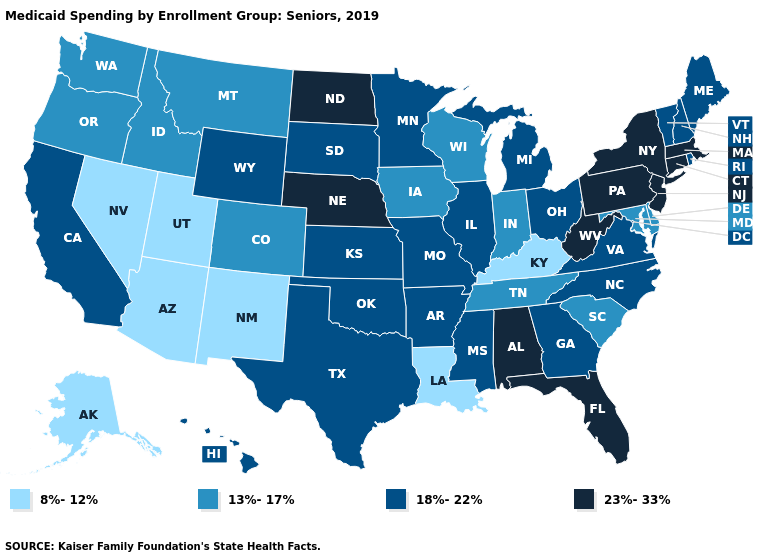What is the lowest value in the USA?
Short answer required. 8%-12%. Does Wyoming have the highest value in the West?
Keep it brief. Yes. What is the highest value in states that border Virginia?
Keep it brief. 23%-33%. What is the value of California?
Give a very brief answer. 18%-22%. Does the map have missing data?
Concise answer only. No. Name the states that have a value in the range 18%-22%?
Keep it brief. Arkansas, California, Georgia, Hawaii, Illinois, Kansas, Maine, Michigan, Minnesota, Mississippi, Missouri, New Hampshire, North Carolina, Ohio, Oklahoma, Rhode Island, South Dakota, Texas, Vermont, Virginia, Wyoming. Which states hav the highest value in the West?
Concise answer only. California, Hawaii, Wyoming. Does Maryland have the highest value in the South?
Give a very brief answer. No. Which states have the highest value in the USA?
Keep it brief. Alabama, Connecticut, Florida, Massachusetts, Nebraska, New Jersey, New York, North Dakota, Pennsylvania, West Virginia. How many symbols are there in the legend?
Concise answer only. 4. What is the value of Massachusetts?
Give a very brief answer. 23%-33%. What is the value of Colorado?
Give a very brief answer. 13%-17%. What is the value of Maine?
Quick response, please. 18%-22%. What is the highest value in the USA?
Short answer required. 23%-33%. Which states hav the highest value in the South?
Answer briefly. Alabama, Florida, West Virginia. 